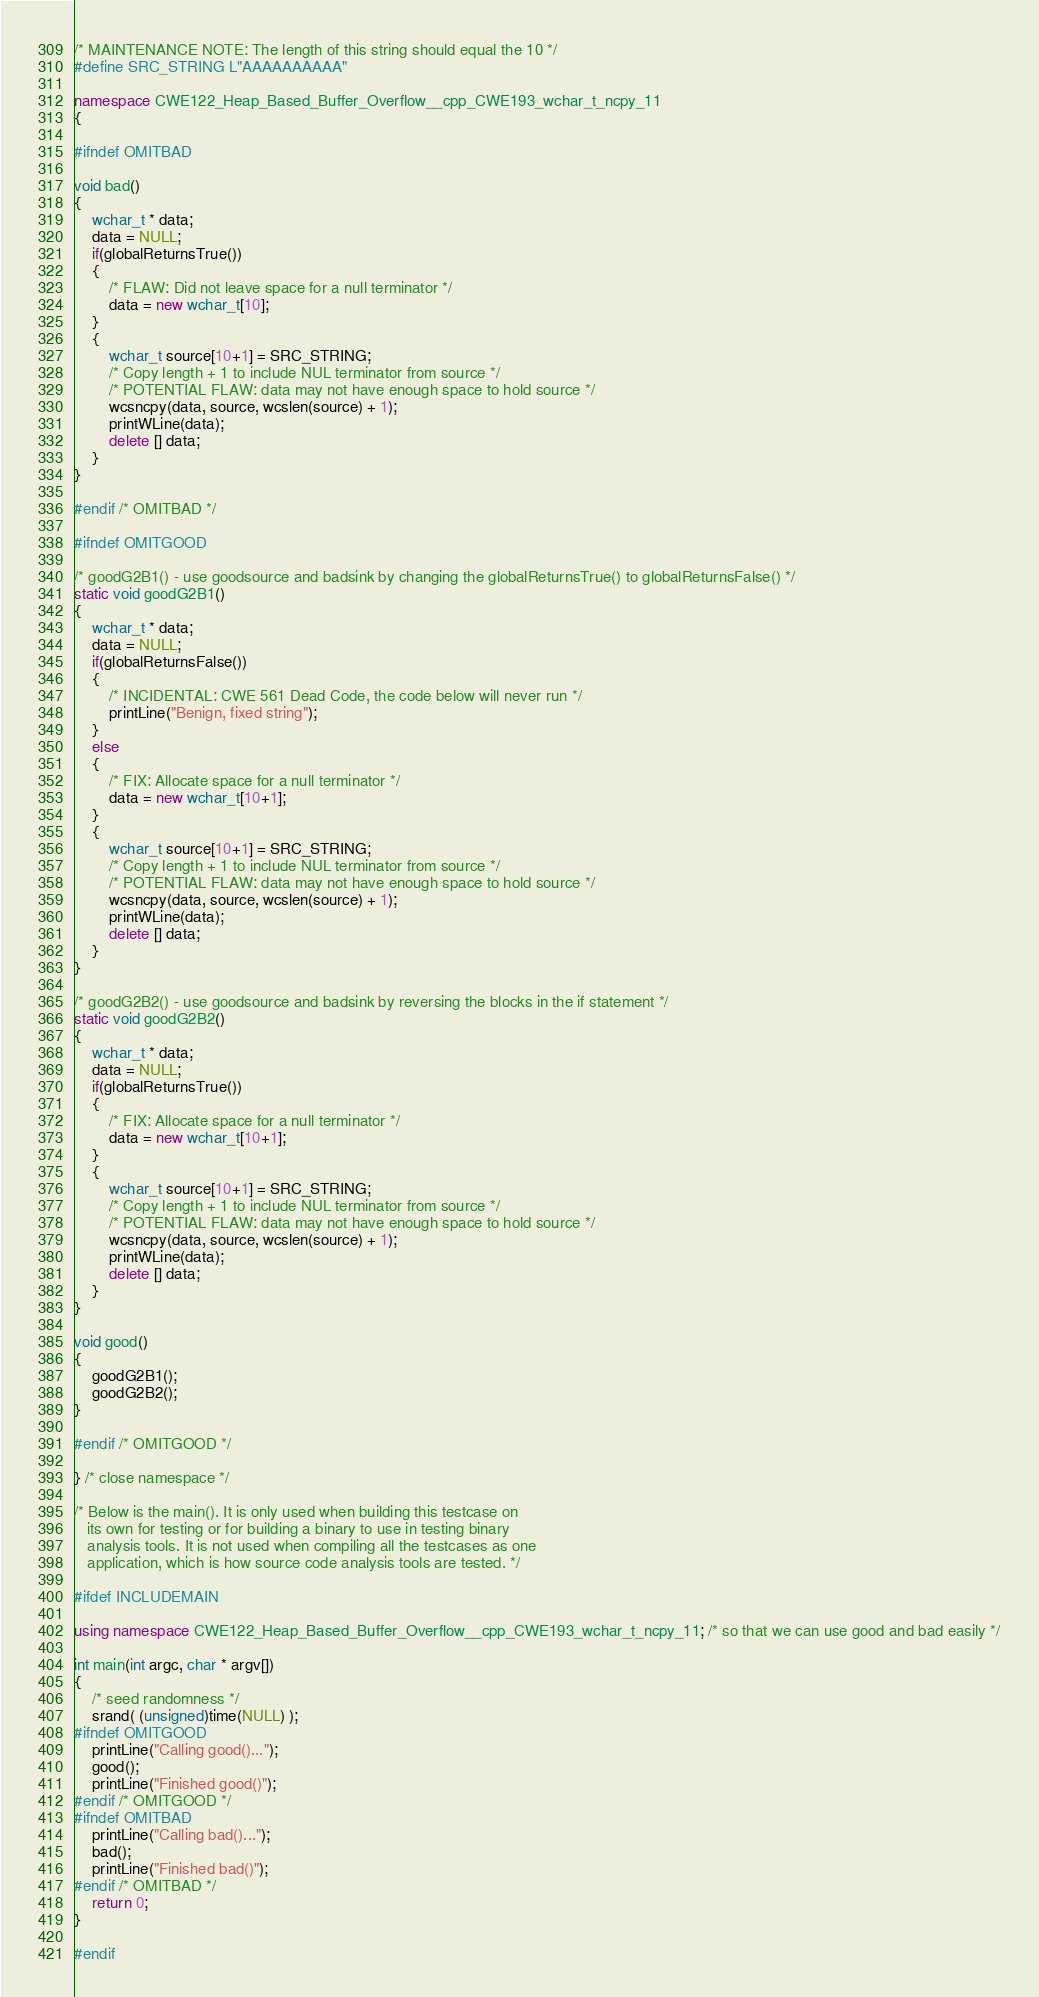<code> <loc_0><loc_0><loc_500><loc_500><_C++_>
/* MAINTENANCE NOTE: The length of this string should equal the 10 */
#define SRC_STRING L"AAAAAAAAAA"

namespace CWE122_Heap_Based_Buffer_Overflow__cpp_CWE193_wchar_t_ncpy_11
{

#ifndef OMITBAD

void bad()
{
    wchar_t * data;
    data = NULL;
    if(globalReturnsTrue())
    {
        /* FLAW: Did not leave space for a null terminator */
        data = new wchar_t[10];
    }
    {
        wchar_t source[10+1] = SRC_STRING;
        /* Copy length + 1 to include NUL terminator from source */
        /* POTENTIAL FLAW: data may not have enough space to hold source */
        wcsncpy(data, source, wcslen(source) + 1);
        printWLine(data);
        delete [] data;
    }
}

#endif /* OMITBAD */

#ifndef OMITGOOD

/* goodG2B1() - use goodsource and badsink by changing the globalReturnsTrue() to globalReturnsFalse() */
static void goodG2B1()
{
    wchar_t * data;
    data = NULL;
    if(globalReturnsFalse())
    {
        /* INCIDENTAL: CWE 561 Dead Code, the code below will never run */
        printLine("Benign, fixed string");
    }
    else
    {
        /* FIX: Allocate space for a null terminator */
        data = new wchar_t[10+1];
    }
    {
        wchar_t source[10+1] = SRC_STRING;
        /* Copy length + 1 to include NUL terminator from source */
        /* POTENTIAL FLAW: data may not have enough space to hold source */
        wcsncpy(data, source, wcslen(source) + 1);
        printWLine(data);
        delete [] data;
    }
}

/* goodG2B2() - use goodsource and badsink by reversing the blocks in the if statement */
static void goodG2B2()
{
    wchar_t * data;
    data = NULL;
    if(globalReturnsTrue())
    {
        /* FIX: Allocate space for a null terminator */
        data = new wchar_t[10+1];
    }
    {
        wchar_t source[10+1] = SRC_STRING;
        /* Copy length + 1 to include NUL terminator from source */
        /* POTENTIAL FLAW: data may not have enough space to hold source */
        wcsncpy(data, source, wcslen(source) + 1);
        printWLine(data);
        delete [] data;
    }
}

void good()
{
    goodG2B1();
    goodG2B2();
}

#endif /* OMITGOOD */

} /* close namespace */

/* Below is the main(). It is only used when building this testcase on
   its own for testing or for building a binary to use in testing binary
   analysis tools. It is not used when compiling all the testcases as one
   application, which is how source code analysis tools are tested. */

#ifdef INCLUDEMAIN

using namespace CWE122_Heap_Based_Buffer_Overflow__cpp_CWE193_wchar_t_ncpy_11; /* so that we can use good and bad easily */

int main(int argc, char * argv[])
{
    /* seed randomness */
    srand( (unsigned)time(NULL) );
#ifndef OMITGOOD
    printLine("Calling good()...");
    good();
    printLine("Finished good()");
#endif /* OMITGOOD */
#ifndef OMITBAD
    printLine("Calling bad()...");
    bad();
    printLine("Finished bad()");
#endif /* OMITBAD */
    return 0;
}

#endif
</code> 